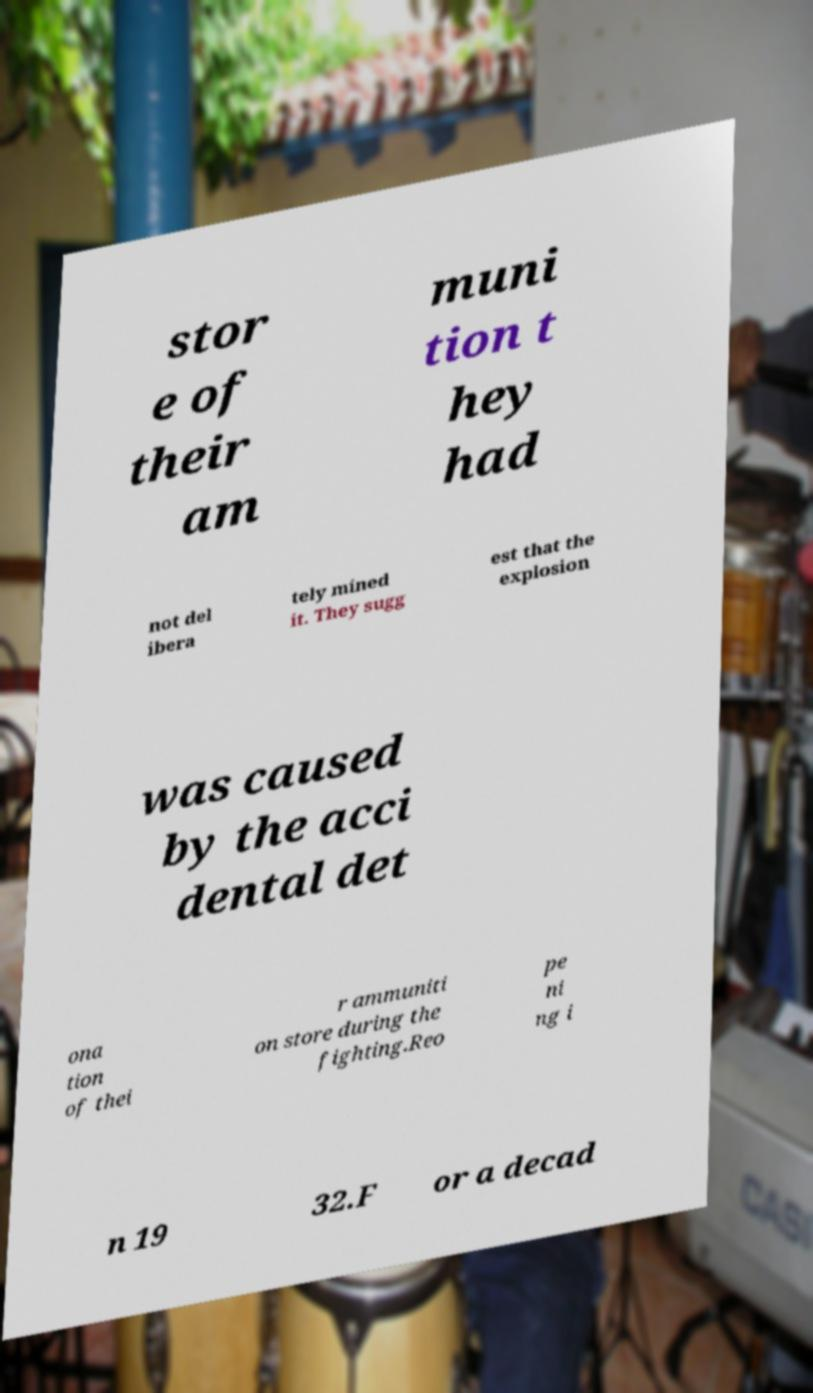I need the written content from this picture converted into text. Can you do that? stor e of their am muni tion t hey had not del ibera tely mined it. They sugg est that the explosion was caused by the acci dental det ona tion of thei r ammuniti on store during the fighting.Reo pe ni ng i n 19 32.F or a decad 